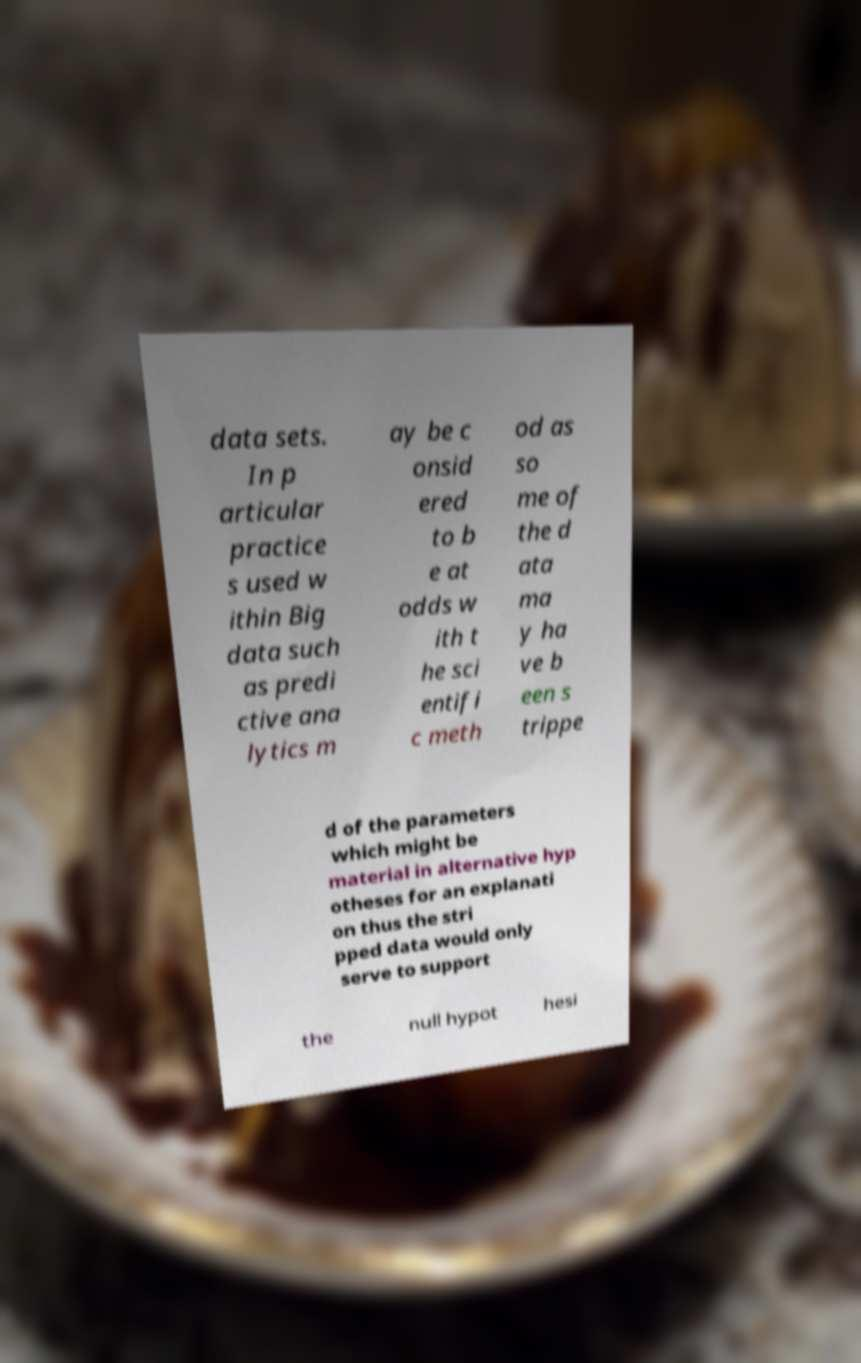There's text embedded in this image that I need extracted. Can you transcribe it verbatim? data sets. In p articular practice s used w ithin Big data such as predi ctive ana lytics m ay be c onsid ered to b e at odds w ith t he sci entifi c meth od as so me of the d ata ma y ha ve b een s trippe d of the parameters which might be material in alternative hyp otheses for an explanati on thus the stri pped data would only serve to support the null hypot hesi 